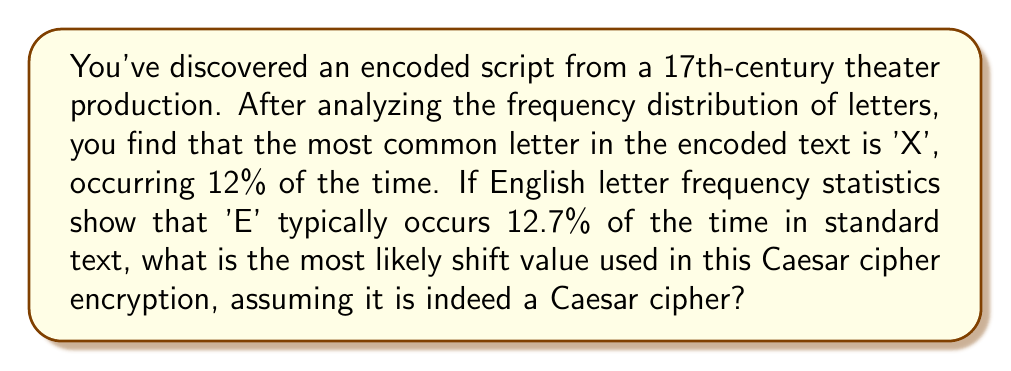Give your solution to this math problem. To solve this problem, we'll follow these steps:

1) In a Caesar cipher, each letter is shifted by a fixed number of positions in the alphabet. We need to find how many positions 'E' was shifted to become 'X'.

2) First, let's assign numeric values to 'E' and 'X':
   E = 4 (5th letter of the alphabet)
   X = 23 (24th letter of the alphabet)

3) To find the shift, we calculate:
   $$(X - E) \mod 26 = (23 - 4) \mod 26 = 19 \mod 26 = 19$$

4) We use modulo 26 because there are 26 letters in the English alphabet, and we want to ensure our result wraps around if it exceeds 26.

5) Therefore, the most likely shift value used in this Caesar cipher encryption is 19.

This means that each letter in the original text was likely shifted 19 positions forward in the alphabet to create the encoded script.
Answer: 19 